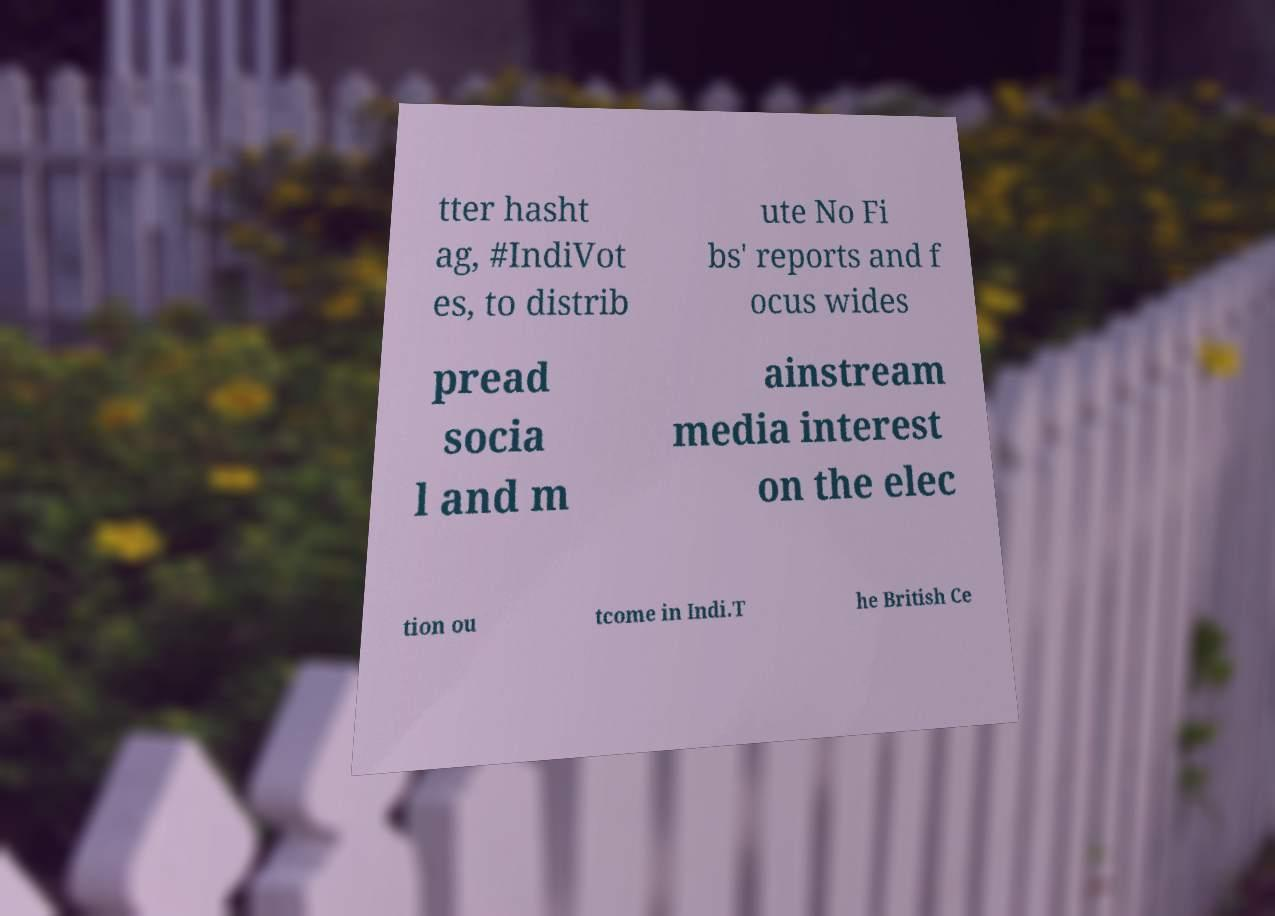Could you extract and type out the text from this image? tter hasht ag, #IndiVot es, to distrib ute No Fi bs' reports and f ocus wides pread socia l and m ainstream media interest on the elec tion ou tcome in Indi.T he British Ce 